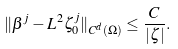<formula> <loc_0><loc_0><loc_500><loc_500>\| \beta ^ { j } - L ^ { 2 } \zeta _ { 0 } ^ { j } \| _ { C ^ { d } ( \Omega ) } \leq \frac { C } { | \zeta | } .</formula> 